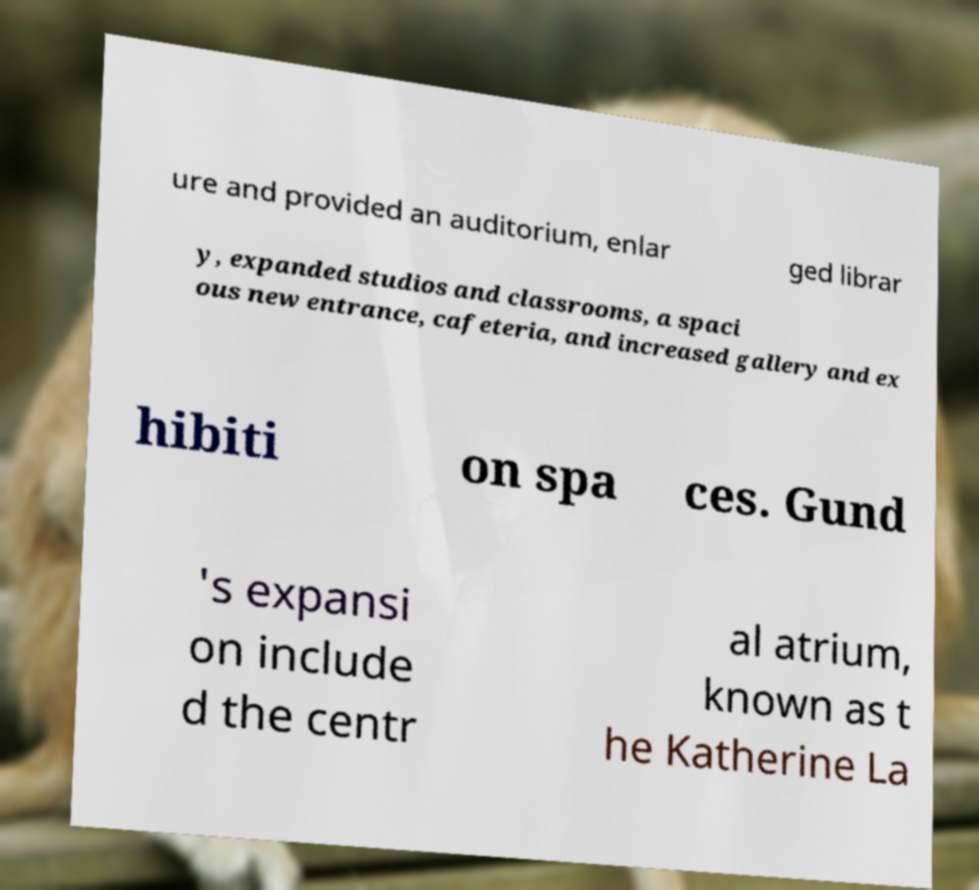Please identify and transcribe the text found in this image. ure and provided an auditorium, enlar ged librar y, expanded studios and classrooms, a spaci ous new entrance, cafeteria, and increased gallery and ex hibiti on spa ces. Gund 's expansi on include d the centr al atrium, known as t he Katherine La 